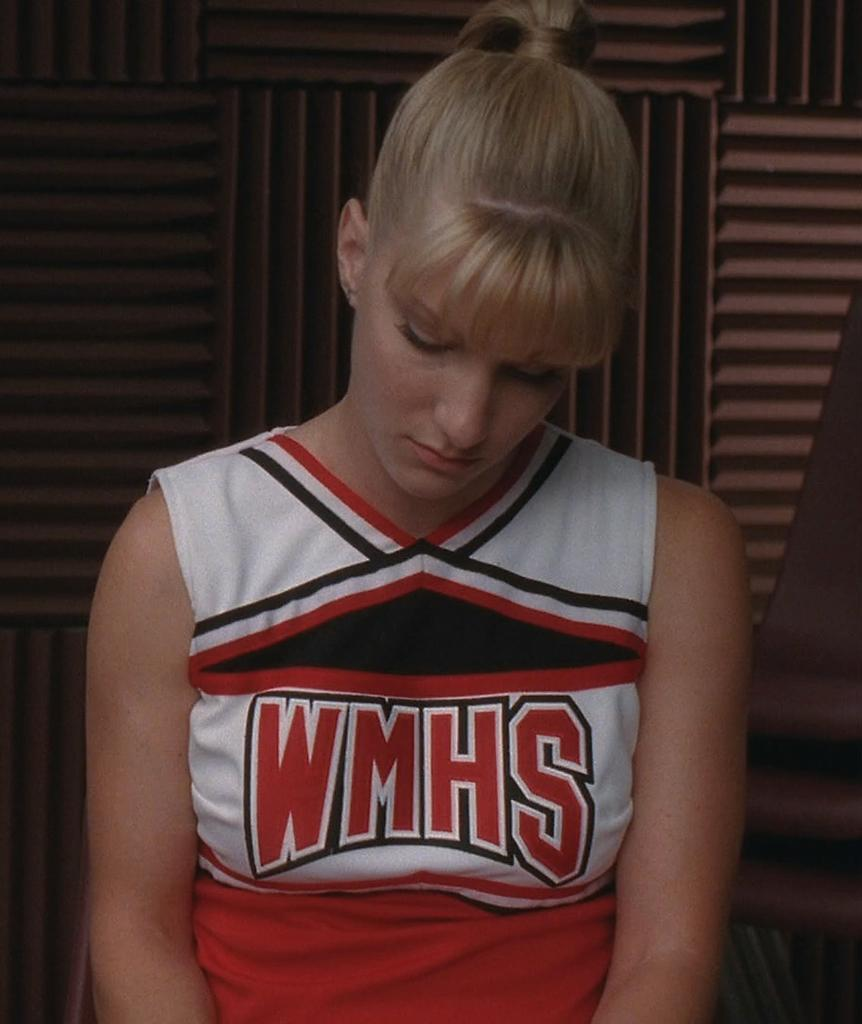<image>
Give a short and clear explanation of the subsequent image. A cheerleader has the letters WMHS on the shirt of her uniform. 